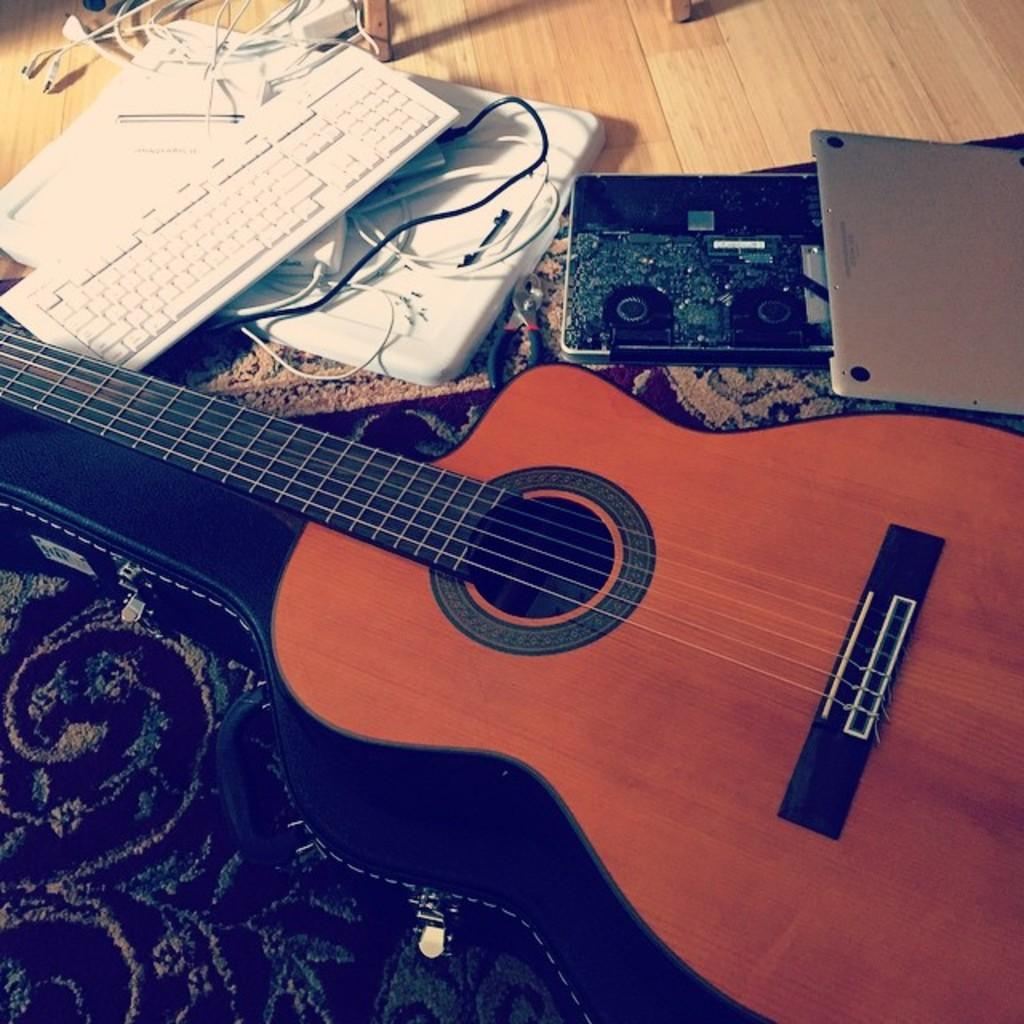What musical instruments can be seen in the image? There is a guitar and a keyboard in the image. What else is present in the image besides the musical instruments? There are wires and other equipment visible in the image. Can you describe the appearance of the cloth in the image? Yes, there is cloth visible in the image. What type of cheese is being used to create the beast's trail in the image? There is no cheese or beast present in the image. 